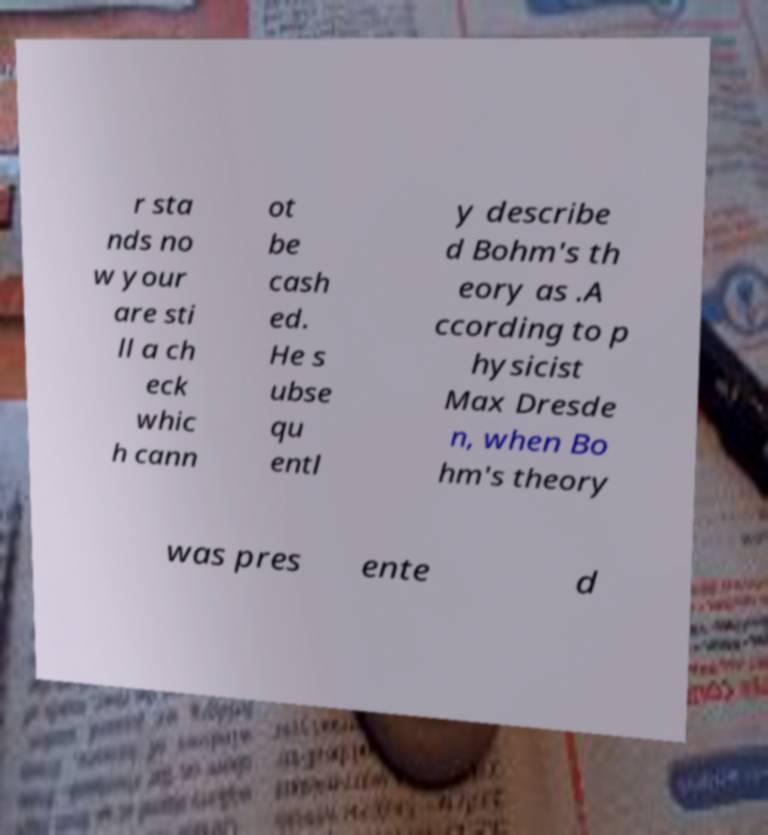For documentation purposes, I need the text within this image transcribed. Could you provide that? r sta nds no w your are sti ll a ch eck whic h cann ot be cash ed. He s ubse qu entl y describe d Bohm's th eory as .A ccording to p hysicist Max Dresde n, when Bo hm's theory was pres ente d 